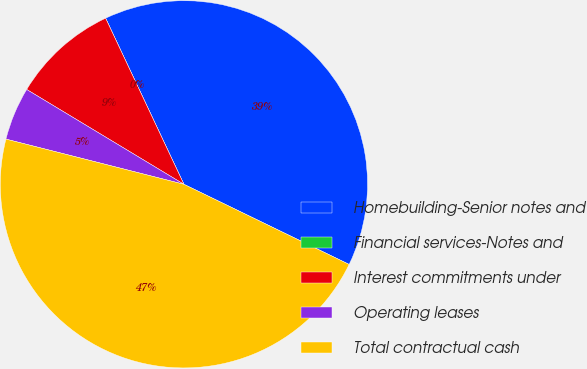<chart> <loc_0><loc_0><loc_500><loc_500><pie_chart><fcel>Homebuilding-Senior notes and<fcel>Financial services-Notes and<fcel>Interest commitments under<fcel>Operating leases<fcel>Total contractual cash<nl><fcel>39.2%<fcel>0.0%<fcel>9.35%<fcel>4.68%<fcel>46.77%<nl></chart> 